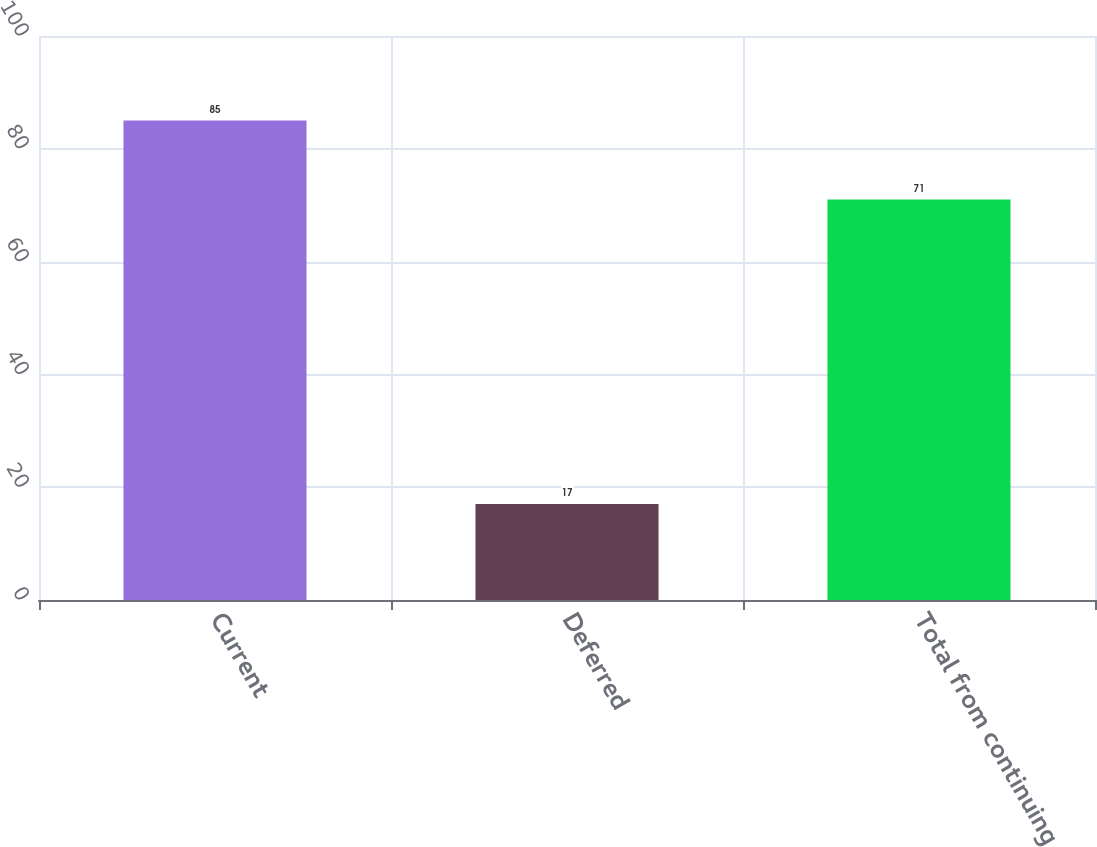<chart> <loc_0><loc_0><loc_500><loc_500><bar_chart><fcel>Current<fcel>Deferred<fcel>Total from continuing<nl><fcel>85<fcel>17<fcel>71<nl></chart> 